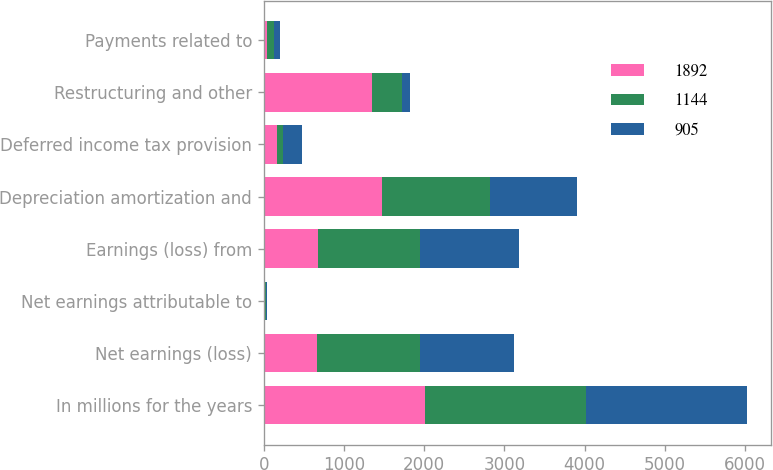Convert chart. <chart><loc_0><loc_0><loc_500><loc_500><stacked_bar_chart><ecel><fcel>In millions for the years<fcel>Net earnings (loss)<fcel>Net earnings attributable to<fcel>Earnings (loss) from<fcel>Depreciation amortization and<fcel>Deferred income tax provision<fcel>Restructuring and other<fcel>Payments related to<nl><fcel>1892<fcel>2009<fcel>663<fcel>18<fcel>681<fcel>1472<fcel>160<fcel>1353<fcel>38<nl><fcel>1144<fcel>2008<fcel>1282<fcel>3<fcel>1266<fcel>1347<fcel>81<fcel>370<fcel>87<nl><fcel>905<fcel>2007<fcel>1168<fcel>24<fcel>1239<fcel>1086<fcel>232<fcel>95<fcel>78<nl></chart> 